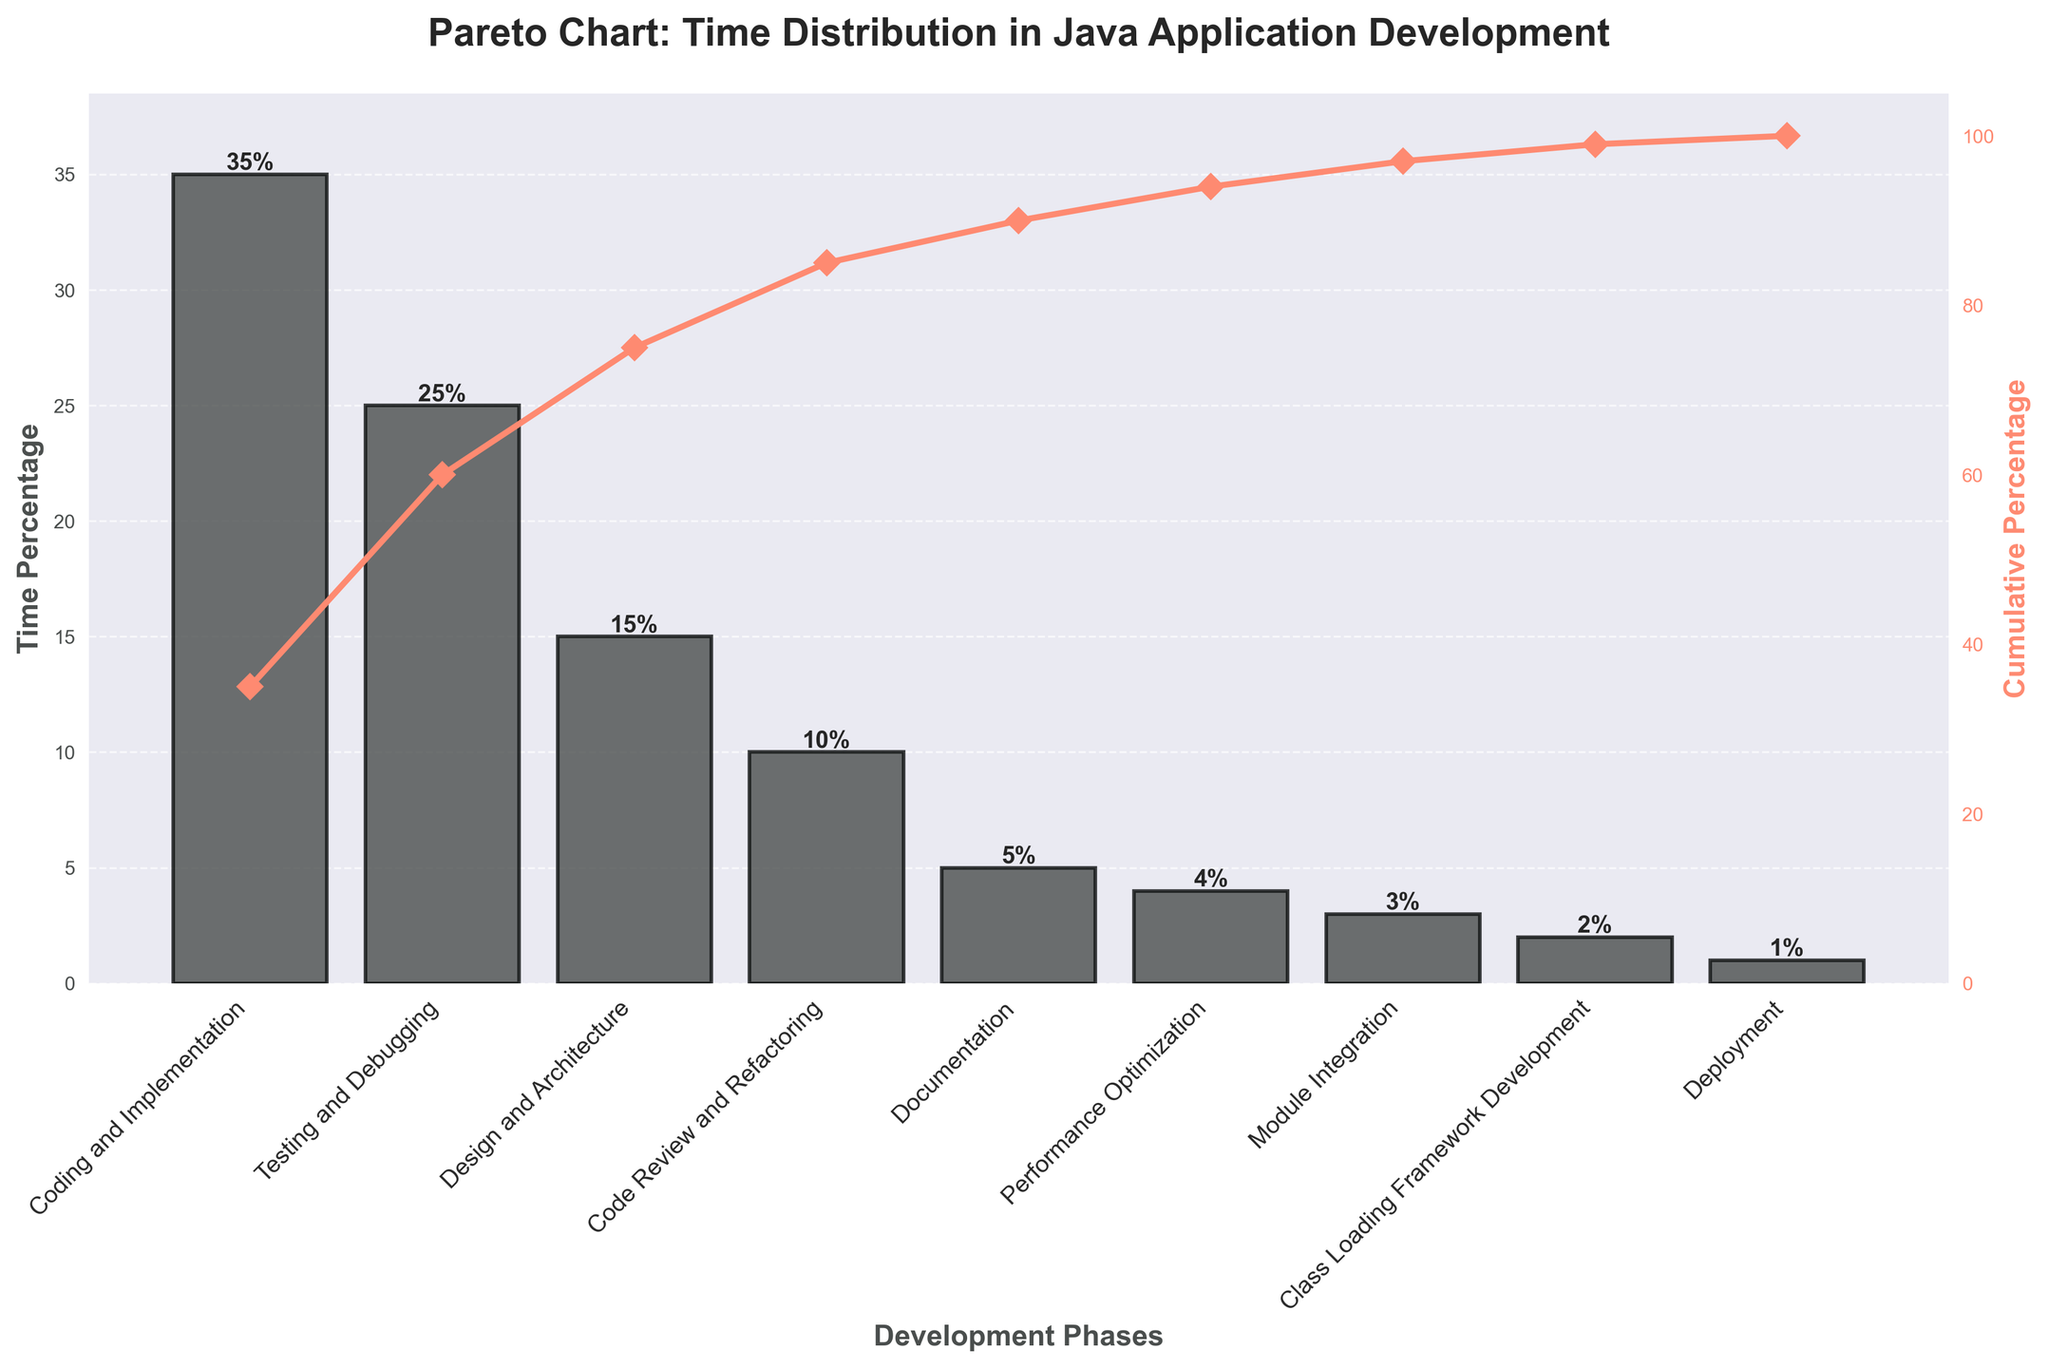What's the most time-consuming phase? The highest bar in the bar chart represents the most time-consuming phase. From the chart, the highest bar corresponds to "Coding and Implementation" with a time percentage of 35%.
Answer: Coding and Implementation What's the least time-consuming phase? The smallest bar in the bar chart represents the least time-consuming phase. From the chart, the smallest bar corresponds to "Deployment" with a time percentage of 1%.
Answer: Deployment What is the cumulative percentage after the 'Testing and Debugging' phase? Find "Testing and Debugging" on the x-axis and follow the associated cumulative percentage line to the second y-axis (right side). The cumulative percentage at this point is 60% (35% from "Coding and Implementation" + 25% from "Testing and Debugging").
Answer: 60% Which phase has a greater time percentage, 'Code Review and Refactoring' or 'Design and Architecture'? Look at the bars for "Code Review and Refactoring" and "Design and Architecture". The bar for "Design and Architecture" is higher with 15% compared to "Code Review and Refactoring" with 10%.
Answer: Design and Architecture How much more time is spent on 'Testing and Debugging' compared to 'Performance Optimization'? The time percentage spent on "Testing and Debugging" is 25% and on "Performance Optimization" is 4%. The difference is 25% - 4% = 21%.
Answer: 21% What is the cumulative percentage by the end of 'Documentation'? Find "Documentation" on the x-axis and follow the cumulative line to the right y-axis. Sum all the percentages up to "Documentation": 35% + 25% + 15% + 10% + 5% = 90%.
Answer: 90% What phases comprise over 70% of the total time spent? Look for the phases until the cumulative percentage exceeds 70%. "Coding and Implementation" (35%) + "Testing and Debugging" (25%) + "Design and Architecture" (15%) = 75%, which includes "Coding and Implementation", "Testing and Debugging", and "Design and Architecture".
Answer: Coding and Implementation, Testing and Debugging, Design and Architecture What's the cumulative percentage after 'Class Loading Framework Development'? Sum the percentages up to "Class Loading Framework Development": 35% + 25% + 15% + 10% + 5% + 4% + 3% + 2% = 99%.
Answer: 99% Which development phase comes second in terms of time allocation after 'Coding and Implementation'? The bar next in height after "Coding and Implementation" represents the second most time-consuming phase, which is "Testing and Debugging" at 25%.
Answer: Testing and Debugging 